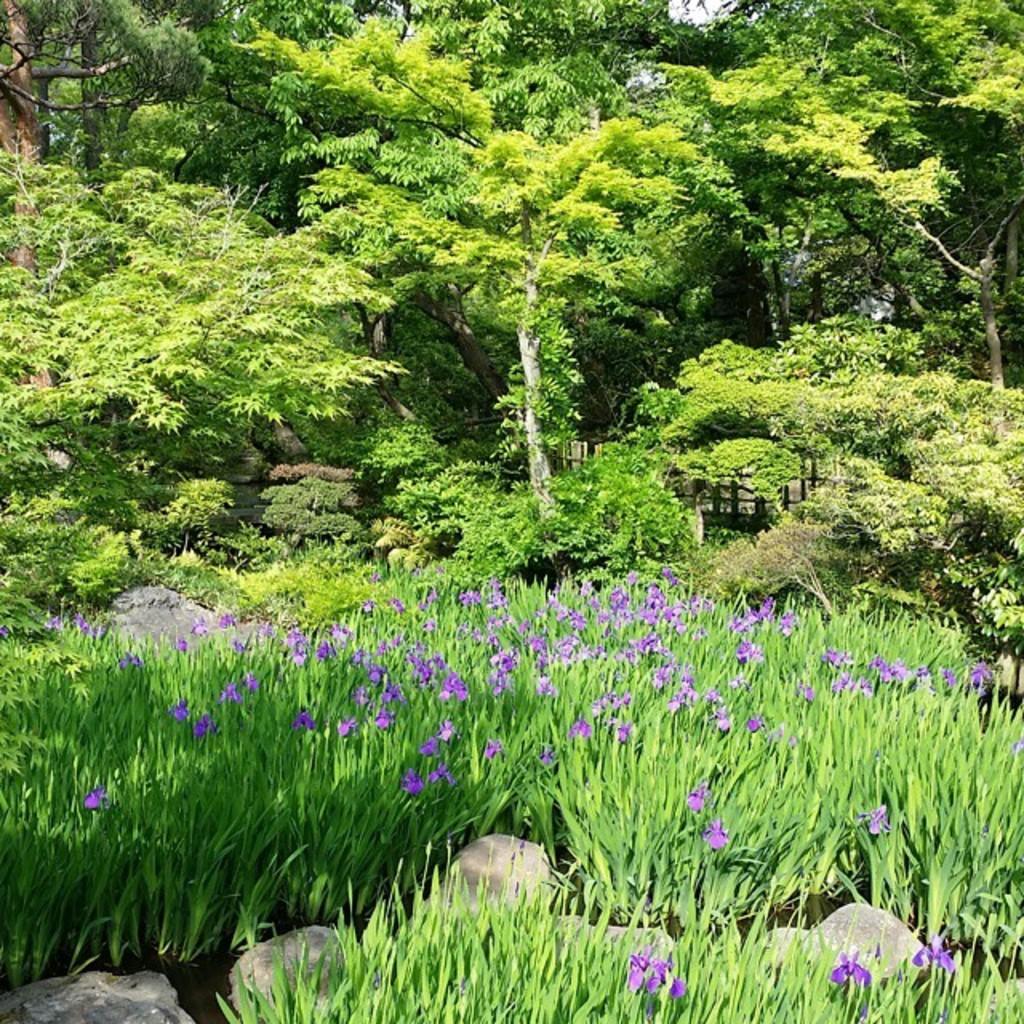Could you give a brief overview of what you see in this image? In this image there are flower plants at the bottom. At the top there are trees. There are some stones in between the plants. 